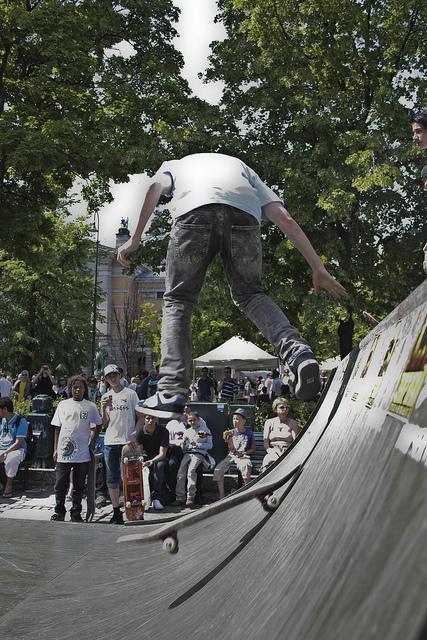How many people can be seen?
Give a very brief answer. 7. 